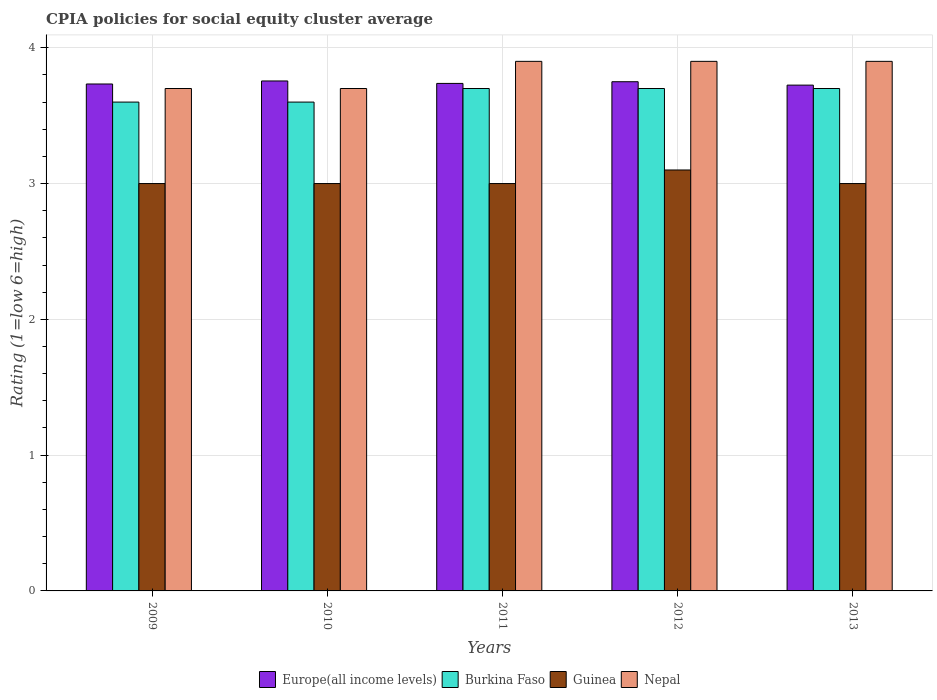How many different coloured bars are there?
Keep it short and to the point. 4. How many groups of bars are there?
Your answer should be compact. 5. What is the CPIA rating in Europe(all income levels) in 2013?
Ensure brevity in your answer.  3.73. Across all years, what is the minimum CPIA rating in Nepal?
Keep it short and to the point. 3.7. In which year was the CPIA rating in Nepal maximum?
Give a very brief answer. 2011. What is the total CPIA rating in Europe(all income levels) in the graph?
Your answer should be very brief. 18.7. What is the difference between the CPIA rating in Guinea in 2011 and that in 2012?
Your answer should be very brief. -0.1. What is the difference between the CPIA rating in Guinea in 2009 and the CPIA rating in Burkina Faso in 2013?
Provide a succinct answer. -0.7. What is the average CPIA rating in Europe(all income levels) per year?
Provide a short and direct response. 3.74. In the year 2011, what is the difference between the CPIA rating in Nepal and CPIA rating in Burkina Faso?
Keep it short and to the point. 0.2. What is the ratio of the CPIA rating in Europe(all income levels) in 2009 to that in 2012?
Make the answer very short. 1. Is the CPIA rating in Burkina Faso in 2011 less than that in 2013?
Keep it short and to the point. No. Is the difference between the CPIA rating in Nepal in 2010 and 2013 greater than the difference between the CPIA rating in Burkina Faso in 2010 and 2013?
Offer a terse response. No. What is the difference between the highest and the second highest CPIA rating in Guinea?
Offer a terse response. 0.1. What is the difference between the highest and the lowest CPIA rating in Burkina Faso?
Give a very brief answer. 0.1. In how many years, is the CPIA rating in Europe(all income levels) greater than the average CPIA rating in Europe(all income levels) taken over all years?
Your answer should be very brief. 2. Is it the case that in every year, the sum of the CPIA rating in Guinea and CPIA rating in Nepal is greater than the sum of CPIA rating in Europe(all income levels) and CPIA rating in Burkina Faso?
Give a very brief answer. No. What does the 4th bar from the left in 2010 represents?
Keep it short and to the point. Nepal. What does the 2nd bar from the right in 2009 represents?
Ensure brevity in your answer.  Guinea. How many bars are there?
Ensure brevity in your answer.  20. How many years are there in the graph?
Your answer should be very brief. 5. What is the difference between two consecutive major ticks on the Y-axis?
Your response must be concise. 1. Does the graph contain any zero values?
Your answer should be compact. No. What is the title of the graph?
Your response must be concise. CPIA policies for social equity cluster average. What is the label or title of the X-axis?
Your response must be concise. Years. What is the label or title of the Y-axis?
Your answer should be very brief. Rating (1=low 6=high). What is the Rating (1=low 6=high) of Europe(all income levels) in 2009?
Keep it short and to the point. 3.73. What is the Rating (1=low 6=high) of Guinea in 2009?
Give a very brief answer. 3. What is the Rating (1=low 6=high) in Nepal in 2009?
Give a very brief answer. 3.7. What is the Rating (1=low 6=high) in Europe(all income levels) in 2010?
Make the answer very short. 3.76. What is the Rating (1=low 6=high) of Guinea in 2010?
Your answer should be compact. 3. What is the Rating (1=low 6=high) of Nepal in 2010?
Offer a very short reply. 3.7. What is the Rating (1=low 6=high) in Europe(all income levels) in 2011?
Your answer should be very brief. 3.74. What is the Rating (1=low 6=high) in Guinea in 2011?
Ensure brevity in your answer.  3. What is the Rating (1=low 6=high) in Nepal in 2011?
Provide a succinct answer. 3.9. What is the Rating (1=low 6=high) of Europe(all income levels) in 2012?
Make the answer very short. 3.75. What is the Rating (1=low 6=high) in Europe(all income levels) in 2013?
Offer a very short reply. 3.73. What is the Rating (1=low 6=high) of Burkina Faso in 2013?
Your response must be concise. 3.7. What is the Rating (1=low 6=high) of Nepal in 2013?
Provide a succinct answer. 3.9. Across all years, what is the maximum Rating (1=low 6=high) in Europe(all income levels)?
Provide a succinct answer. 3.76. Across all years, what is the maximum Rating (1=low 6=high) in Burkina Faso?
Your answer should be very brief. 3.7. Across all years, what is the maximum Rating (1=low 6=high) of Nepal?
Your answer should be very brief. 3.9. Across all years, what is the minimum Rating (1=low 6=high) of Europe(all income levels)?
Your answer should be compact. 3.73. Across all years, what is the minimum Rating (1=low 6=high) in Burkina Faso?
Your answer should be very brief. 3.6. Across all years, what is the minimum Rating (1=low 6=high) in Nepal?
Offer a terse response. 3.7. What is the total Rating (1=low 6=high) of Europe(all income levels) in the graph?
Provide a succinct answer. 18.7. What is the total Rating (1=low 6=high) of Burkina Faso in the graph?
Keep it short and to the point. 18.3. What is the total Rating (1=low 6=high) in Nepal in the graph?
Ensure brevity in your answer.  19.1. What is the difference between the Rating (1=low 6=high) of Europe(all income levels) in 2009 and that in 2010?
Keep it short and to the point. -0.02. What is the difference between the Rating (1=low 6=high) in Burkina Faso in 2009 and that in 2010?
Make the answer very short. 0. What is the difference between the Rating (1=low 6=high) in Guinea in 2009 and that in 2010?
Provide a succinct answer. 0. What is the difference between the Rating (1=low 6=high) in Nepal in 2009 and that in 2010?
Keep it short and to the point. 0. What is the difference between the Rating (1=low 6=high) in Europe(all income levels) in 2009 and that in 2011?
Provide a succinct answer. -0. What is the difference between the Rating (1=low 6=high) of Burkina Faso in 2009 and that in 2011?
Offer a very short reply. -0.1. What is the difference between the Rating (1=low 6=high) of Europe(all income levels) in 2009 and that in 2012?
Offer a very short reply. -0.02. What is the difference between the Rating (1=low 6=high) in Burkina Faso in 2009 and that in 2012?
Give a very brief answer. -0.1. What is the difference between the Rating (1=low 6=high) of Guinea in 2009 and that in 2012?
Give a very brief answer. -0.1. What is the difference between the Rating (1=low 6=high) of Europe(all income levels) in 2009 and that in 2013?
Make the answer very short. 0.01. What is the difference between the Rating (1=low 6=high) of Burkina Faso in 2009 and that in 2013?
Offer a terse response. -0.1. What is the difference between the Rating (1=low 6=high) of Nepal in 2009 and that in 2013?
Your answer should be very brief. -0.2. What is the difference between the Rating (1=low 6=high) in Europe(all income levels) in 2010 and that in 2011?
Your answer should be very brief. 0.02. What is the difference between the Rating (1=low 6=high) of Europe(all income levels) in 2010 and that in 2012?
Offer a very short reply. 0.01. What is the difference between the Rating (1=low 6=high) in Guinea in 2010 and that in 2012?
Make the answer very short. -0.1. What is the difference between the Rating (1=low 6=high) of Europe(all income levels) in 2010 and that in 2013?
Give a very brief answer. 0.03. What is the difference between the Rating (1=low 6=high) of Burkina Faso in 2010 and that in 2013?
Offer a terse response. -0.1. What is the difference between the Rating (1=low 6=high) in Europe(all income levels) in 2011 and that in 2012?
Keep it short and to the point. -0.01. What is the difference between the Rating (1=low 6=high) in Burkina Faso in 2011 and that in 2012?
Your response must be concise. 0. What is the difference between the Rating (1=low 6=high) in Europe(all income levels) in 2011 and that in 2013?
Ensure brevity in your answer.  0.01. What is the difference between the Rating (1=low 6=high) in Nepal in 2011 and that in 2013?
Make the answer very short. 0. What is the difference between the Rating (1=low 6=high) in Europe(all income levels) in 2012 and that in 2013?
Offer a very short reply. 0.03. What is the difference between the Rating (1=low 6=high) in Burkina Faso in 2012 and that in 2013?
Provide a short and direct response. 0. What is the difference between the Rating (1=low 6=high) of Nepal in 2012 and that in 2013?
Provide a succinct answer. 0. What is the difference between the Rating (1=low 6=high) of Europe(all income levels) in 2009 and the Rating (1=low 6=high) of Burkina Faso in 2010?
Provide a short and direct response. 0.13. What is the difference between the Rating (1=low 6=high) of Europe(all income levels) in 2009 and the Rating (1=low 6=high) of Guinea in 2010?
Offer a very short reply. 0.73. What is the difference between the Rating (1=low 6=high) in Europe(all income levels) in 2009 and the Rating (1=low 6=high) in Nepal in 2010?
Keep it short and to the point. 0.03. What is the difference between the Rating (1=low 6=high) in Burkina Faso in 2009 and the Rating (1=low 6=high) in Guinea in 2010?
Keep it short and to the point. 0.6. What is the difference between the Rating (1=low 6=high) in Europe(all income levels) in 2009 and the Rating (1=low 6=high) in Burkina Faso in 2011?
Provide a succinct answer. 0.03. What is the difference between the Rating (1=low 6=high) in Europe(all income levels) in 2009 and the Rating (1=low 6=high) in Guinea in 2011?
Your response must be concise. 0.73. What is the difference between the Rating (1=low 6=high) of Europe(all income levels) in 2009 and the Rating (1=low 6=high) of Nepal in 2011?
Provide a short and direct response. -0.17. What is the difference between the Rating (1=low 6=high) of Burkina Faso in 2009 and the Rating (1=low 6=high) of Nepal in 2011?
Provide a short and direct response. -0.3. What is the difference between the Rating (1=low 6=high) of Europe(all income levels) in 2009 and the Rating (1=low 6=high) of Burkina Faso in 2012?
Offer a very short reply. 0.03. What is the difference between the Rating (1=low 6=high) in Europe(all income levels) in 2009 and the Rating (1=low 6=high) in Guinea in 2012?
Offer a very short reply. 0.63. What is the difference between the Rating (1=low 6=high) in Burkina Faso in 2009 and the Rating (1=low 6=high) in Guinea in 2012?
Your answer should be compact. 0.5. What is the difference between the Rating (1=low 6=high) of Guinea in 2009 and the Rating (1=low 6=high) of Nepal in 2012?
Keep it short and to the point. -0.9. What is the difference between the Rating (1=low 6=high) of Europe(all income levels) in 2009 and the Rating (1=low 6=high) of Burkina Faso in 2013?
Provide a succinct answer. 0.03. What is the difference between the Rating (1=low 6=high) in Europe(all income levels) in 2009 and the Rating (1=low 6=high) in Guinea in 2013?
Offer a terse response. 0.73. What is the difference between the Rating (1=low 6=high) in Burkina Faso in 2009 and the Rating (1=low 6=high) in Guinea in 2013?
Make the answer very short. 0.6. What is the difference between the Rating (1=low 6=high) of Guinea in 2009 and the Rating (1=low 6=high) of Nepal in 2013?
Offer a very short reply. -0.9. What is the difference between the Rating (1=low 6=high) of Europe(all income levels) in 2010 and the Rating (1=low 6=high) of Burkina Faso in 2011?
Provide a succinct answer. 0.06. What is the difference between the Rating (1=low 6=high) of Europe(all income levels) in 2010 and the Rating (1=low 6=high) of Guinea in 2011?
Make the answer very short. 0.76. What is the difference between the Rating (1=low 6=high) in Europe(all income levels) in 2010 and the Rating (1=low 6=high) in Nepal in 2011?
Ensure brevity in your answer.  -0.14. What is the difference between the Rating (1=low 6=high) in Burkina Faso in 2010 and the Rating (1=low 6=high) in Guinea in 2011?
Your response must be concise. 0.6. What is the difference between the Rating (1=low 6=high) in Europe(all income levels) in 2010 and the Rating (1=low 6=high) in Burkina Faso in 2012?
Offer a terse response. 0.06. What is the difference between the Rating (1=low 6=high) in Europe(all income levels) in 2010 and the Rating (1=low 6=high) in Guinea in 2012?
Give a very brief answer. 0.66. What is the difference between the Rating (1=low 6=high) in Europe(all income levels) in 2010 and the Rating (1=low 6=high) in Nepal in 2012?
Keep it short and to the point. -0.14. What is the difference between the Rating (1=low 6=high) of Europe(all income levels) in 2010 and the Rating (1=low 6=high) of Burkina Faso in 2013?
Provide a short and direct response. 0.06. What is the difference between the Rating (1=low 6=high) of Europe(all income levels) in 2010 and the Rating (1=low 6=high) of Guinea in 2013?
Your answer should be compact. 0.76. What is the difference between the Rating (1=low 6=high) of Europe(all income levels) in 2010 and the Rating (1=low 6=high) of Nepal in 2013?
Offer a terse response. -0.14. What is the difference between the Rating (1=low 6=high) in Burkina Faso in 2010 and the Rating (1=low 6=high) in Nepal in 2013?
Offer a very short reply. -0.3. What is the difference between the Rating (1=low 6=high) of Europe(all income levels) in 2011 and the Rating (1=low 6=high) of Burkina Faso in 2012?
Offer a terse response. 0.04. What is the difference between the Rating (1=low 6=high) in Europe(all income levels) in 2011 and the Rating (1=low 6=high) in Guinea in 2012?
Your answer should be compact. 0.64. What is the difference between the Rating (1=low 6=high) in Europe(all income levels) in 2011 and the Rating (1=low 6=high) in Nepal in 2012?
Make the answer very short. -0.16. What is the difference between the Rating (1=low 6=high) in Europe(all income levels) in 2011 and the Rating (1=low 6=high) in Burkina Faso in 2013?
Your response must be concise. 0.04. What is the difference between the Rating (1=low 6=high) of Europe(all income levels) in 2011 and the Rating (1=low 6=high) of Guinea in 2013?
Give a very brief answer. 0.74. What is the difference between the Rating (1=low 6=high) in Europe(all income levels) in 2011 and the Rating (1=low 6=high) in Nepal in 2013?
Provide a succinct answer. -0.16. What is the difference between the Rating (1=low 6=high) of Burkina Faso in 2011 and the Rating (1=low 6=high) of Nepal in 2013?
Offer a terse response. -0.2. What is the difference between the Rating (1=low 6=high) in Europe(all income levels) in 2012 and the Rating (1=low 6=high) in Nepal in 2013?
Your answer should be very brief. -0.15. What is the difference between the Rating (1=low 6=high) in Guinea in 2012 and the Rating (1=low 6=high) in Nepal in 2013?
Provide a succinct answer. -0.8. What is the average Rating (1=low 6=high) of Europe(all income levels) per year?
Keep it short and to the point. 3.74. What is the average Rating (1=low 6=high) in Burkina Faso per year?
Ensure brevity in your answer.  3.66. What is the average Rating (1=low 6=high) in Guinea per year?
Make the answer very short. 3.02. What is the average Rating (1=low 6=high) of Nepal per year?
Ensure brevity in your answer.  3.82. In the year 2009, what is the difference between the Rating (1=low 6=high) in Europe(all income levels) and Rating (1=low 6=high) in Burkina Faso?
Provide a succinct answer. 0.13. In the year 2009, what is the difference between the Rating (1=low 6=high) in Europe(all income levels) and Rating (1=low 6=high) in Guinea?
Provide a short and direct response. 0.73. In the year 2009, what is the difference between the Rating (1=low 6=high) in Europe(all income levels) and Rating (1=low 6=high) in Nepal?
Ensure brevity in your answer.  0.03. In the year 2009, what is the difference between the Rating (1=low 6=high) of Burkina Faso and Rating (1=low 6=high) of Guinea?
Your response must be concise. 0.6. In the year 2009, what is the difference between the Rating (1=low 6=high) of Burkina Faso and Rating (1=low 6=high) of Nepal?
Your answer should be compact. -0.1. In the year 2009, what is the difference between the Rating (1=low 6=high) of Guinea and Rating (1=low 6=high) of Nepal?
Your answer should be very brief. -0.7. In the year 2010, what is the difference between the Rating (1=low 6=high) of Europe(all income levels) and Rating (1=low 6=high) of Burkina Faso?
Ensure brevity in your answer.  0.16. In the year 2010, what is the difference between the Rating (1=low 6=high) in Europe(all income levels) and Rating (1=low 6=high) in Guinea?
Offer a terse response. 0.76. In the year 2010, what is the difference between the Rating (1=low 6=high) in Europe(all income levels) and Rating (1=low 6=high) in Nepal?
Provide a succinct answer. 0.06. In the year 2010, what is the difference between the Rating (1=low 6=high) in Burkina Faso and Rating (1=low 6=high) in Nepal?
Ensure brevity in your answer.  -0.1. In the year 2010, what is the difference between the Rating (1=low 6=high) in Guinea and Rating (1=low 6=high) in Nepal?
Your answer should be compact. -0.7. In the year 2011, what is the difference between the Rating (1=low 6=high) of Europe(all income levels) and Rating (1=low 6=high) of Burkina Faso?
Provide a short and direct response. 0.04. In the year 2011, what is the difference between the Rating (1=low 6=high) in Europe(all income levels) and Rating (1=low 6=high) in Guinea?
Offer a very short reply. 0.74. In the year 2011, what is the difference between the Rating (1=low 6=high) in Europe(all income levels) and Rating (1=low 6=high) in Nepal?
Provide a succinct answer. -0.16. In the year 2011, what is the difference between the Rating (1=low 6=high) in Burkina Faso and Rating (1=low 6=high) in Nepal?
Provide a succinct answer. -0.2. In the year 2011, what is the difference between the Rating (1=low 6=high) in Guinea and Rating (1=low 6=high) in Nepal?
Offer a terse response. -0.9. In the year 2012, what is the difference between the Rating (1=low 6=high) of Europe(all income levels) and Rating (1=low 6=high) of Burkina Faso?
Offer a terse response. 0.05. In the year 2012, what is the difference between the Rating (1=low 6=high) of Europe(all income levels) and Rating (1=low 6=high) of Guinea?
Offer a very short reply. 0.65. In the year 2012, what is the difference between the Rating (1=low 6=high) of Europe(all income levels) and Rating (1=low 6=high) of Nepal?
Offer a very short reply. -0.15. In the year 2012, what is the difference between the Rating (1=low 6=high) in Burkina Faso and Rating (1=low 6=high) in Nepal?
Provide a short and direct response. -0.2. In the year 2013, what is the difference between the Rating (1=low 6=high) in Europe(all income levels) and Rating (1=low 6=high) in Burkina Faso?
Offer a terse response. 0.03. In the year 2013, what is the difference between the Rating (1=low 6=high) of Europe(all income levels) and Rating (1=low 6=high) of Guinea?
Provide a succinct answer. 0.72. In the year 2013, what is the difference between the Rating (1=low 6=high) of Europe(all income levels) and Rating (1=low 6=high) of Nepal?
Provide a succinct answer. -0.17. In the year 2013, what is the difference between the Rating (1=low 6=high) in Burkina Faso and Rating (1=low 6=high) in Nepal?
Your response must be concise. -0.2. What is the ratio of the Rating (1=low 6=high) in Burkina Faso in 2009 to that in 2010?
Offer a very short reply. 1. What is the ratio of the Rating (1=low 6=high) of Guinea in 2009 to that in 2010?
Offer a very short reply. 1. What is the ratio of the Rating (1=low 6=high) in Nepal in 2009 to that in 2010?
Your response must be concise. 1. What is the ratio of the Rating (1=low 6=high) of Europe(all income levels) in 2009 to that in 2011?
Provide a succinct answer. 1. What is the ratio of the Rating (1=low 6=high) in Guinea in 2009 to that in 2011?
Provide a succinct answer. 1. What is the ratio of the Rating (1=low 6=high) of Nepal in 2009 to that in 2011?
Keep it short and to the point. 0.95. What is the ratio of the Rating (1=low 6=high) of Europe(all income levels) in 2009 to that in 2012?
Make the answer very short. 1. What is the ratio of the Rating (1=low 6=high) of Nepal in 2009 to that in 2012?
Your answer should be compact. 0.95. What is the ratio of the Rating (1=low 6=high) of Europe(all income levels) in 2009 to that in 2013?
Ensure brevity in your answer.  1. What is the ratio of the Rating (1=low 6=high) of Burkina Faso in 2009 to that in 2013?
Your response must be concise. 0.97. What is the ratio of the Rating (1=low 6=high) of Guinea in 2009 to that in 2013?
Offer a very short reply. 1. What is the ratio of the Rating (1=low 6=high) of Nepal in 2009 to that in 2013?
Make the answer very short. 0.95. What is the ratio of the Rating (1=low 6=high) in Europe(all income levels) in 2010 to that in 2011?
Provide a succinct answer. 1. What is the ratio of the Rating (1=low 6=high) in Burkina Faso in 2010 to that in 2011?
Offer a terse response. 0.97. What is the ratio of the Rating (1=low 6=high) in Guinea in 2010 to that in 2011?
Keep it short and to the point. 1. What is the ratio of the Rating (1=low 6=high) of Nepal in 2010 to that in 2011?
Make the answer very short. 0.95. What is the ratio of the Rating (1=low 6=high) in Europe(all income levels) in 2010 to that in 2012?
Keep it short and to the point. 1. What is the ratio of the Rating (1=low 6=high) in Burkina Faso in 2010 to that in 2012?
Provide a short and direct response. 0.97. What is the ratio of the Rating (1=low 6=high) of Guinea in 2010 to that in 2012?
Your response must be concise. 0.97. What is the ratio of the Rating (1=low 6=high) in Nepal in 2010 to that in 2012?
Ensure brevity in your answer.  0.95. What is the ratio of the Rating (1=low 6=high) in Europe(all income levels) in 2010 to that in 2013?
Your answer should be compact. 1.01. What is the ratio of the Rating (1=low 6=high) in Guinea in 2010 to that in 2013?
Offer a terse response. 1. What is the ratio of the Rating (1=low 6=high) of Nepal in 2010 to that in 2013?
Provide a succinct answer. 0.95. What is the ratio of the Rating (1=low 6=high) of Burkina Faso in 2011 to that in 2012?
Provide a succinct answer. 1. What is the ratio of the Rating (1=low 6=high) of Guinea in 2011 to that in 2012?
Keep it short and to the point. 0.97. What is the ratio of the Rating (1=low 6=high) in Nepal in 2011 to that in 2012?
Offer a terse response. 1. What is the ratio of the Rating (1=low 6=high) of Burkina Faso in 2011 to that in 2013?
Give a very brief answer. 1. What is the ratio of the Rating (1=low 6=high) of Guinea in 2011 to that in 2013?
Keep it short and to the point. 1. What is the ratio of the Rating (1=low 6=high) of Nepal in 2011 to that in 2013?
Your answer should be compact. 1. What is the ratio of the Rating (1=low 6=high) in Guinea in 2012 to that in 2013?
Offer a very short reply. 1.03. What is the difference between the highest and the second highest Rating (1=low 6=high) of Europe(all income levels)?
Your answer should be very brief. 0.01. What is the difference between the highest and the second highest Rating (1=low 6=high) in Burkina Faso?
Keep it short and to the point. 0. What is the difference between the highest and the lowest Rating (1=low 6=high) of Europe(all income levels)?
Your response must be concise. 0.03. What is the difference between the highest and the lowest Rating (1=low 6=high) in Guinea?
Your response must be concise. 0.1. What is the difference between the highest and the lowest Rating (1=low 6=high) of Nepal?
Your answer should be compact. 0.2. 